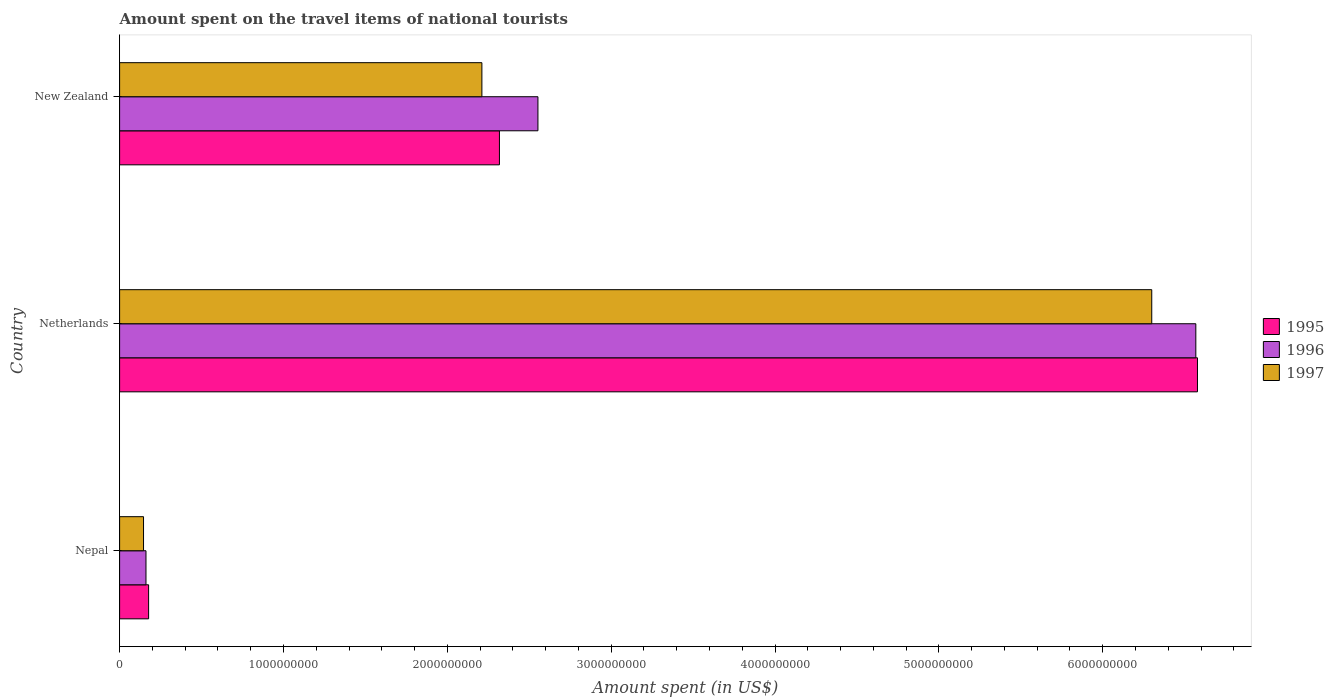How many groups of bars are there?
Offer a terse response. 3. Are the number of bars per tick equal to the number of legend labels?
Provide a short and direct response. Yes. Are the number of bars on each tick of the Y-axis equal?
Make the answer very short. Yes. How many bars are there on the 3rd tick from the top?
Offer a terse response. 3. How many bars are there on the 3rd tick from the bottom?
Ensure brevity in your answer.  3. What is the label of the 1st group of bars from the top?
Your response must be concise. New Zealand. What is the amount spent on the travel items of national tourists in 1996 in New Zealand?
Your answer should be compact. 2.55e+09. Across all countries, what is the maximum amount spent on the travel items of national tourists in 1996?
Make the answer very short. 6.57e+09. Across all countries, what is the minimum amount spent on the travel items of national tourists in 1997?
Offer a terse response. 1.46e+08. In which country was the amount spent on the travel items of national tourists in 1995 maximum?
Provide a succinct answer. Netherlands. In which country was the amount spent on the travel items of national tourists in 1995 minimum?
Your response must be concise. Nepal. What is the total amount spent on the travel items of national tourists in 1997 in the graph?
Offer a very short reply. 8.66e+09. What is the difference between the amount spent on the travel items of national tourists in 1995 in Nepal and that in New Zealand?
Your response must be concise. -2.14e+09. What is the difference between the amount spent on the travel items of national tourists in 1995 in New Zealand and the amount spent on the travel items of national tourists in 1996 in Netherlands?
Your response must be concise. -4.25e+09. What is the average amount spent on the travel items of national tourists in 1995 per country?
Your answer should be compact. 3.02e+09. What is the difference between the amount spent on the travel items of national tourists in 1995 and amount spent on the travel items of national tourists in 1996 in New Zealand?
Provide a short and direct response. -2.35e+08. In how many countries, is the amount spent on the travel items of national tourists in 1997 greater than 6200000000 US$?
Your answer should be very brief. 1. What is the ratio of the amount spent on the travel items of national tourists in 1995 in Netherlands to that in New Zealand?
Ensure brevity in your answer.  2.84. Is the amount spent on the travel items of national tourists in 1996 in Nepal less than that in Netherlands?
Your response must be concise. Yes. What is the difference between the highest and the second highest amount spent on the travel items of national tourists in 1997?
Offer a very short reply. 4.09e+09. What is the difference between the highest and the lowest amount spent on the travel items of national tourists in 1995?
Provide a short and direct response. 6.40e+09. Is the sum of the amount spent on the travel items of national tourists in 1997 in Netherlands and New Zealand greater than the maximum amount spent on the travel items of national tourists in 1995 across all countries?
Provide a short and direct response. Yes. Is it the case that in every country, the sum of the amount spent on the travel items of national tourists in 1996 and amount spent on the travel items of national tourists in 1995 is greater than the amount spent on the travel items of national tourists in 1997?
Make the answer very short. Yes. How many bars are there?
Your response must be concise. 9. Are all the bars in the graph horizontal?
Keep it short and to the point. Yes. Where does the legend appear in the graph?
Offer a very short reply. Center right. How many legend labels are there?
Provide a short and direct response. 3. What is the title of the graph?
Offer a terse response. Amount spent on the travel items of national tourists. What is the label or title of the X-axis?
Provide a short and direct response. Amount spent (in US$). What is the Amount spent (in US$) in 1995 in Nepal?
Provide a succinct answer. 1.77e+08. What is the Amount spent (in US$) of 1996 in Nepal?
Your answer should be very brief. 1.61e+08. What is the Amount spent (in US$) of 1997 in Nepal?
Your answer should be compact. 1.46e+08. What is the Amount spent (in US$) of 1995 in Netherlands?
Make the answer very short. 6.58e+09. What is the Amount spent (in US$) of 1996 in Netherlands?
Your answer should be very brief. 6.57e+09. What is the Amount spent (in US$) in 1997 in Netherlands?
Your answer should be very brief. 6.30e+09. What is the Amount spent (in US$) of 1995 in New Zealand?
Your answer should be very brief. 2.32e+09. What is the Amount spent (in US$) in 1996 in New Zealand?
Make the answer very short. 2.55e+09. What is the Amount spent (in US$) in 1997 in New Zealand?
Give a very brief answer. 2.21e+09. Across all countries, what is the maximum Amount spent (in US$) in 1995?
Keep it short and to the point. 6.58e+09. Across all countries, what is the maximum Amount spent (in US$) of 1996?
Ensure brevity in your answer.  6.57e+09. Across all countries, what is the maximum Amount spent (in US$) of 1997?
Your answer should be compact. 6.30e+09. Across all countries, what is the minimum Amount spent (in US$) in 1995?
Your answer should be very brief. 1.77e+08. Across all countries, what is the minimum Amount spent (in US$) of 1996?
Provide a succinct answer. 1.61e+08. Across all countries, what is the minimum Amount spent (in US$) in 1997?
Keep it short and to the point. 1.46e+08. What is the total Amount spent (in US$) of 1995 in the graph?
Offer a very short reply. 9.07e+09. What is the total Amount spent (in US$) of 1996 in the graph?
Make the answer very short. 9.28e+09. What is the total Amount spent (in US$) of 1997 in the graph?
Provide a short and direct response. 8.66e+09. What is the difference between the Amount spent (in US$) in 1995 in Nepal and that in Netherlands?
Offer a terse response. -6.40e+09. What is the difference between the Amount spent (in US$) in 1996 in Nepal and that in Netherlands?
Ensure brevity in your answer.  -6.41e+09. What is the difference between the Amount spent (in US$) of 1997 in Nepal and that in Netherlands?
Offer a very short reply. -6.15e+09. What is the difference between the Amount spent (in US$) in 1995 in Nepal and that in New Zealand?
Provide a short and direct response. -2.14e+09. What is the difference between the Amount spent (in US$) in 1996 in Nepal and that in New Zealand?
Your answer should be compact. -2.39e+09. What is the difference between the Amount spent (in US$) of 1997 in Nepal and that in New Zealand?
Provide a short and direct response. -2.06e+09. What is the difference between the Amount spent (in US$) in 1995 in Netherlands and that in New Zealand?
Provide a succinct answer. 4.26e+09. What is the difference between the Amount spent (in US$) in 1996 in Netherlands and that in New Zealand?
Your response must be concise. 4.02e+09. What is the difference between the Amount spent (in US$) of 1997 in Netherlands and that in New Zealand?
Provide a succinct answer. 4.09e+09. What is the difference between the Amount spent (in US$) of 1995 in Nepal and the Amount spent (in US$) of 1996 in Netherlands?
Make the answer very short. -6.39e+09. What is the difference between the Amount spent (in US$) in 1995 in Nepal and the Amount spent (in US$) in 1997 in Netherlands?
Keep it short and to the point. -6.12e+09. What is the difference between the Amount spent (in US$) in 1996 in Nepal and the Amount spent (in US$) in 1997 in Netherlands?
Give a very brief answer. -6.14e+09. What is the difference between the Amount spent (in US$) in 1995 in Nepal and the Amount spent (in US$) in 1996 in New Zealand?
Your answer should be very brief. -2.38e+09. What is the difference between the Amount spent (in US$) in 1995 in Nepal and the Amount spent (in US$) in 1997 in New Zealand?
Ensure brevity in your answer.  -2.03e+09. What is the difference between the Amount spent (in US$) of 1996 in Nepal and the Amount spent (in US$) of 1997 in New Zealand?
Give a very brief answer. -2.05e+09. What is the difference between the Amount spent (in US$) in 1995 in Netherlands and the Amount spent (in US$) in 1996 in New Zealand?
Offer a very short reply. 4.02e+09. What is the difference between the Amount spent (in US$) of 1995 in Netherlands and the Amount spent (in US$) of 1997 in New Zealand?
Keep it short and to the point. 4.37e+09. What is the difference between the Amount spent (in US$) in 1996 in Netherlands and the Amount spent (in US$) in 1997 in New Zealand?
Give a very brief answer. 4.36e+09. What is the average Amount spent (in US$) of 1995 per country?
Provide a short and direct response. 3.02e+09. What is the average Amount spent (in US$) in 1996 per country?
Your answer should be compact. 3.09e+09. What is the average Amount spent (in US$) in 1997 per country?
Your answer should be very brief. 2.89e+09. What is the difference between the Amount spent (in US$) of 1995 and Amount spent (in US$) of 1996 in Nepal?
Keep it short and to the point. 1.60e+07. What is the difference between the Amount spent (in US$) in 1995 and Amount spent (in US$) in 1997 in Nepal?
Keep it short and to the point. 3.10e+07. What is the difference between the Amount spent (in US$) of 1996 and Amount spent (in US$) of 1997 in Nepal?
Offer a terse response. 1.50e+07. What is the difference between the Amount spent (in US$) of 1995 and Amount spent (in US$) of 1996 in Netherlands?
Your response must be concise. 1.00e+07. What is the difference between the Amount spent (in US$) in 1995 and Amount spent (in US$) in 1997 in Netherlands?
Offer a terse response. 2.79e+08. What is the difference between the Amount spent (in US$) in 1996 and Amount spent (in US$) in 1997 in Netherlands?
Your answer should be very brief. 2.69e+08. What is the difference between the Amount spent (in US$) in 1995 and Amount spent (in US$) in 1996 in New Zealand?
Your answer should be compact. -2.35e+08. What is the difference between the Amount spent (in US$) of 1995 and Amount spent (in US$) of 1997 in New Zealand?
Provide a short and direct response. 1.07e+08. What is the difference between the Amount spent (in US$) in 1996 and Amount spent (in US$) in 1997 in New Zealand?
Offer a terse response. 3.42e+08. What is the ratio of the Amount spent (in US$) in 1995 in Nepal to that in Netherlands?
Your answer should be compact. 0.03. What is the ratio of the Amount spent (in US$) in 1996 in Nepal to that in Netherlands?
Your answer should be very brief. 0.02. What is the ratio of the Amount spent (in US$) in 1997 in Nepal to that in Netherlands?
Make the answer very short. 0.02. What is the ratio of the Amount spent (in US$) of 1995 in Nepal to that in New Zealand?
Keep it short and to the point. 0.08. What is the ratio of the Amount spent (in US$) of 1996 in Nepal to that in New Zealand?
Offer a terse response. 0.06. What is the ratio of the Amount spent (in US$) in 1997 in Nepal to that in New Zealand?
Provide a succinct answer. 0.07. What is the ratio of the Amount spent (in US$) in 1995 in Netherlands to that in New Zealand?
Keep it short and to the point. 2.84. What is the ratio of the Amount spent (in US$) of 1996 in Netherlands to that in New Zealand?
Ensure brevity in your answer.  2.57. What is the ratio of the Amount spent (in US$) in 1997 in Netherlands to that in New Zealand?
Offer a terse response. 2.85. What is the difference between the highest and the second highest Amount spent (in US$) of 1995?
Make the answer very short. 4.26e+09. What is the difference between the highest and the second highest Amount spent (in US$) of 1996?
Give a very brief answer. 4.02e+09. What is the difference between the highest and the second highest Amount spent (in US$) of 1997?
Keep it short and to the point. 4.09e+09. What is the difference between the highest and the lowest Amount spent (in US$) in 1995?
Ensure brevity in your answer.  6.40e+09. What is the difference between the highest and the lowest Amount spent (in US$) in 1996?
Your answer should be very brief. 6.41e+09. What is the difference between the highest and the lowest Amount spent (in US$) in 1997?
Give a very brief answer. 6.15e+09. 